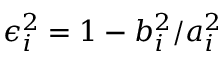<formula> <loc_0><loc_0><loc_500><loc_500>\epsilon _ { i } ^ { 2 } = 1 - b _ { i } ^ { 2 } / a _ { i } ^ { 2 }</formula> 